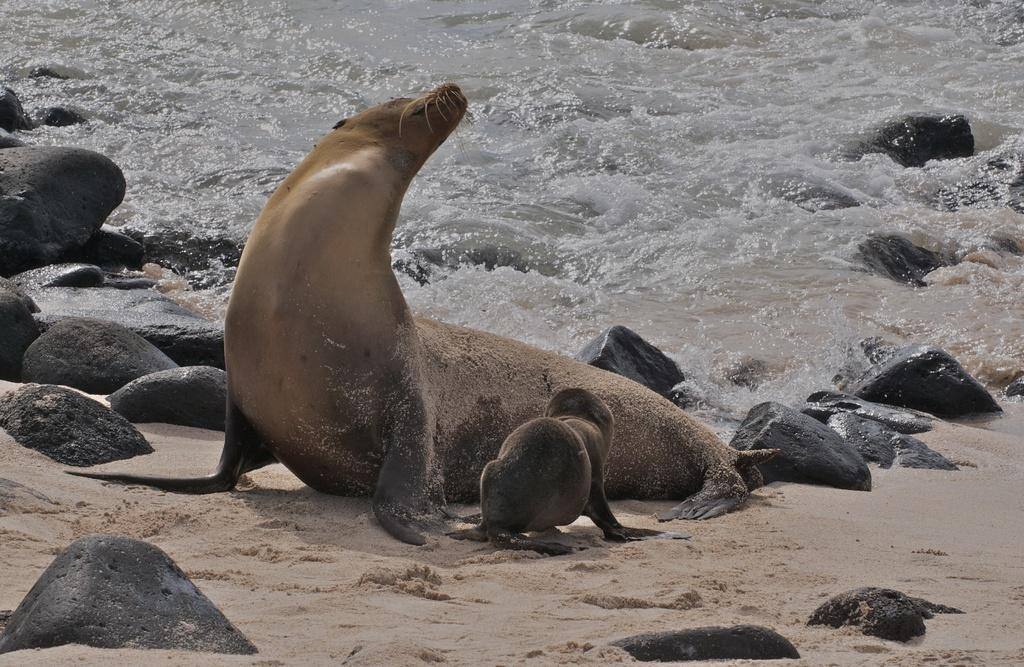What type of animal is in the image? There is a sea lion in the image. Are there any baby sea lions in the image? Yes, there is a baby sea lion in the image. Where are the sea lions located in the image? Both sea lions are on the sand. What can be seen in the background of the image? The background of the image includes water. What other elements are present in the image? There are many stones in the image. What type of slave is depicted in the image? There is no slave depicted in the image; it features sea lions on the sand. What color is the silver in the image? There is no silver present in the image. 